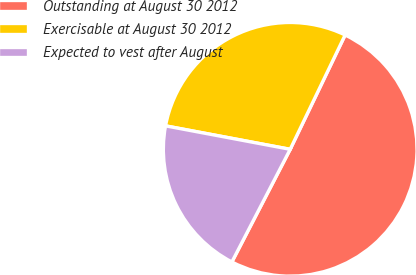Convert chart to OTSL. <chart><loc_0><loc_0><loc_500><loc_500><pie_chart><fcel>Outstanding at August 30 2012<fcel>Exercisable at August 30 2012<fcel>Expected to vest after August<nl><fcel>50.47%<fcel>29.17%<fcel>20.36%<nl></chart> 